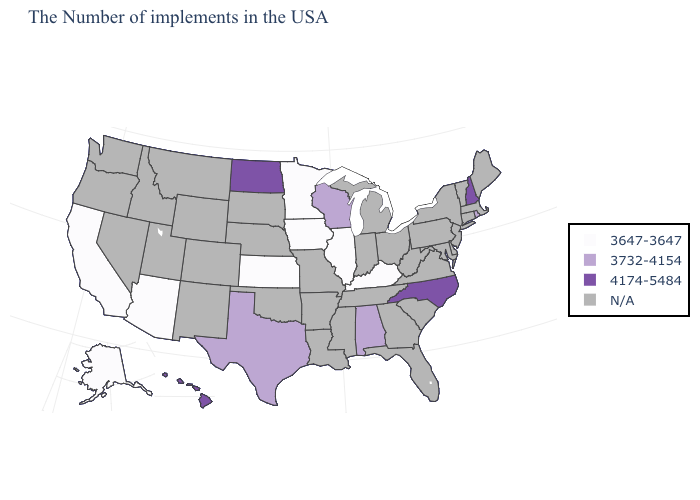Name the states that have a value in the range 3732-4154?
Give a very brief answer. Rhode Island, Alabama, Wisconsin, Texas. What is the value of Arkansas?
Concise answer only. N/A. What is the value of Colorado?
Answer briefly. N/A. Does Texas have the lowest value in the South?
Quick response, please. No. What is the highest value in the Northeast ?
Be succinct. 4174-5484. What is the value of Hawaii?
Quick response, please. 4174-5484. What is the lowest value in the West?
Concise answer only. 3647-3647. What is the value of Vermont?
Write a very short answer. N/A. Which states hav the highest value in the MidWest?
Answer briefly. North Dakota. Does North Carolina have the highest value in the South?
Answer briefly. Yes. Name the states that have a value in the range N/A?
Write a very short answer. Maine, Massachusetts, Vermont, Connecticut, New York, New Jersey, Delaware, Maryland, Pennsylvania, Virginia, South Carolina, West Virginia, Ohio, Florida, Georgia, Michigan, Indiana, Tennessee, Mississippi, Louisiana, Missouri, Arkansas, Nebraska, Oklahoma, South Dakota, Wyoming, Colorado, New Mexico, Utah, Montana, Idaho, Nevada, Washington, Oregon. 